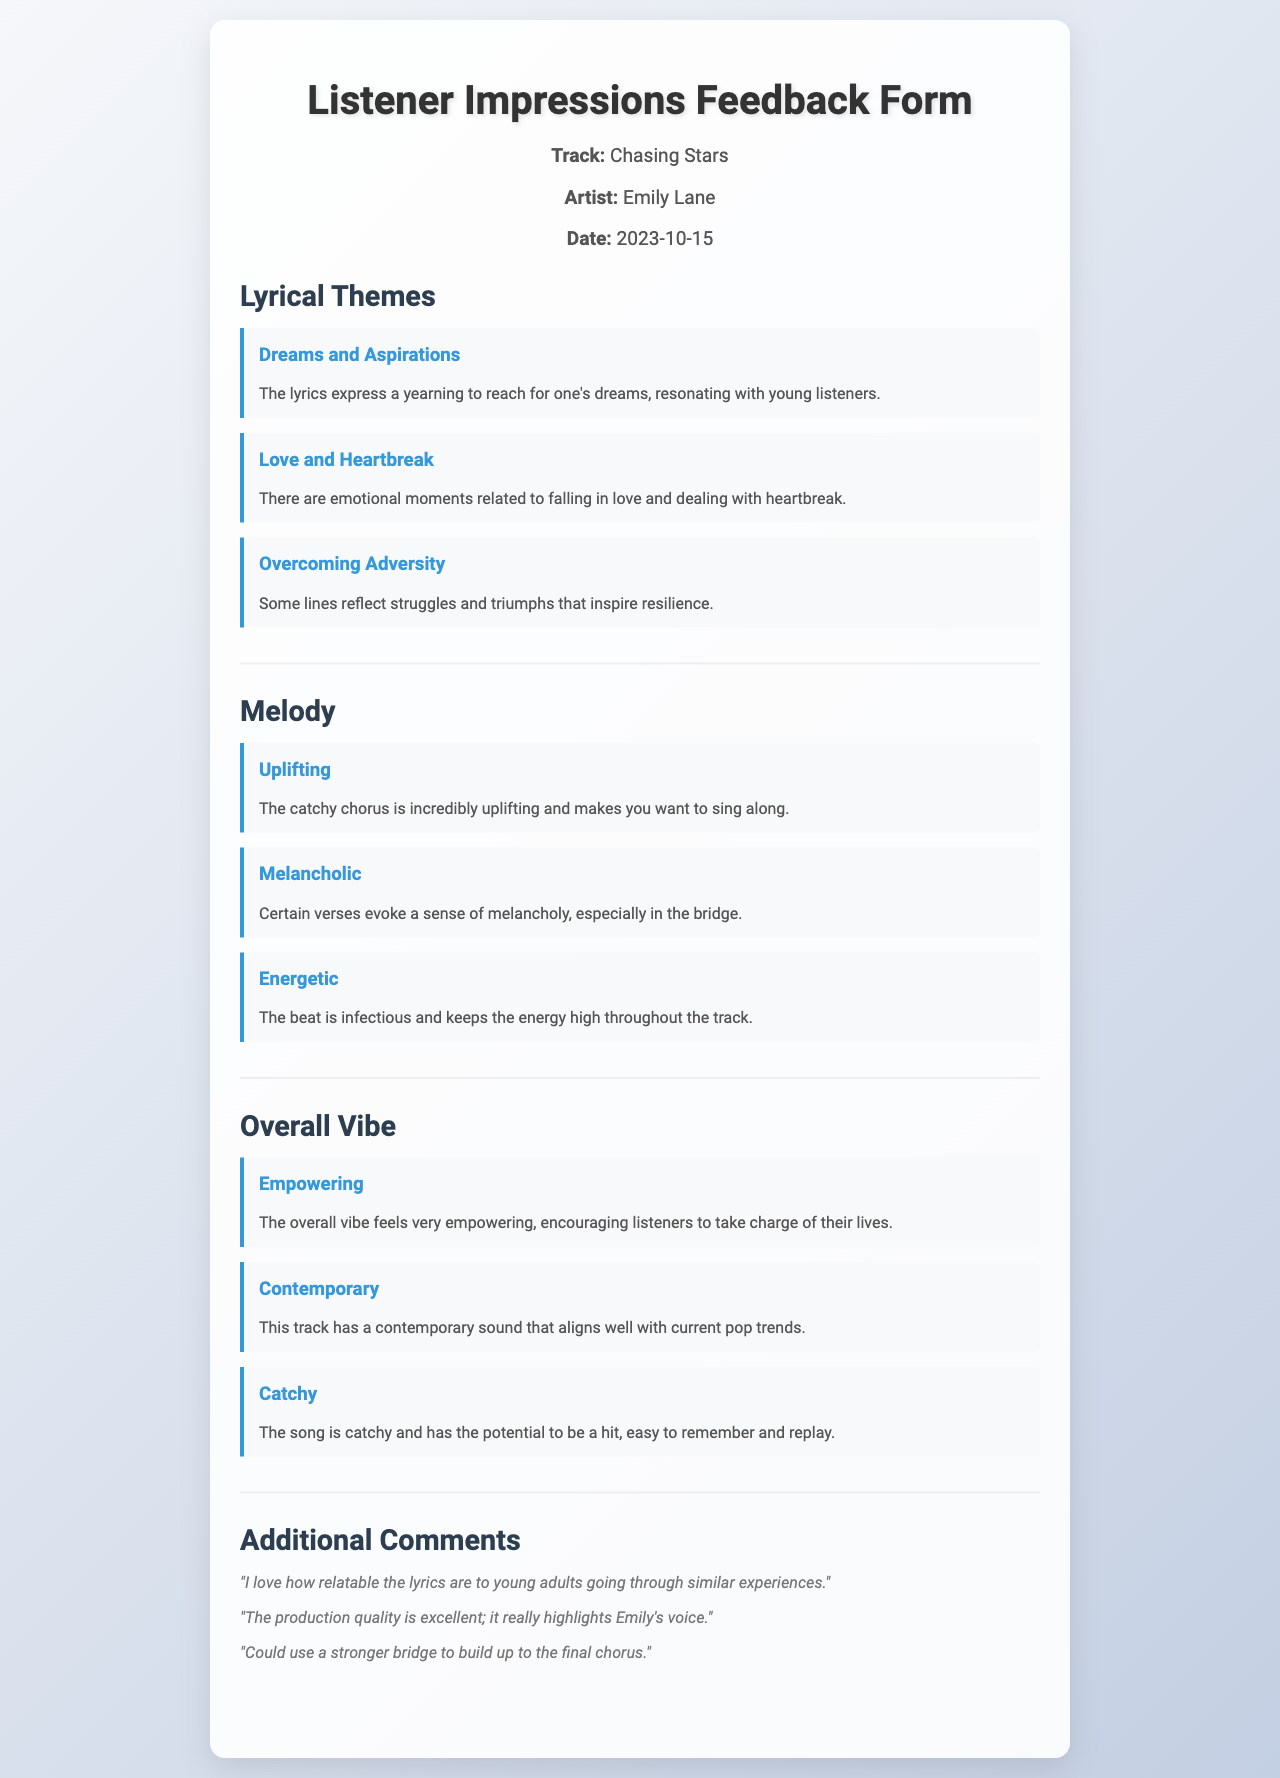What is the title of the track? The title of the track is listed at the top of the document under "Track," which is "Chasing Stars."
Answer: Chasing Stars Who is the artist of the track? The artist's name is mentioned alongside the track title, which is "Emily Lane."
Answer: Emily Lane When was the feedback form filled out? The date is specified in the document as "2023-10-15."
Answer: 2023-10-15 What are the main lyrical themes mentioned? The document lists several themes under "Lyrical Themes," including "Dreams and Aspirations," "Love and Heartbreak," and "Overcoming Adversity."
Answer: Dreams and Aspirations, Love and Heartbreak, Overcoming Adversity What type of mood does the song's melody convey according to the responses? The respondents describe the melody with terms such as "Uplifting," "Melancholic," and "Energetic."
Answer: Uplifting, Melancholic, Energetic How does the overall vibe of the track feel to listeners? Listener impressions categorize the overall vibe as "Empowering," "Contemporary," and "Catchy."
Answer: Empowering, Contemporary, Catchy What additional comments were made about the production quality? Additional comments note that "The production quality is excellent; it really highlights Emily's voice."
Answer: The production quality is excellent; it really highlights Emily's voice What is suggested for improvement in the additional comments? One of the comments indicates that the track "Could use a stronger bridge to build up to the final chorus."
Answer: Could use a stronger bridge to build up to the final chorus 